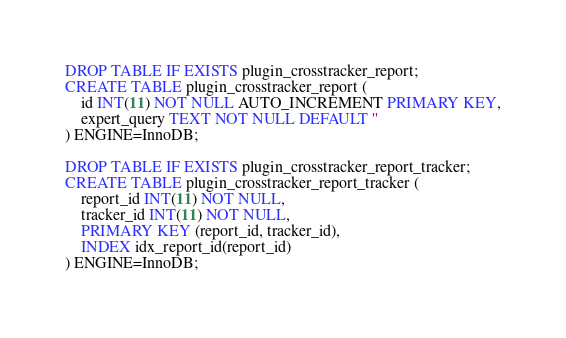<code> <loc_0><loc_0><loc_500><loc_500><_SQL_>DROP TABLE IF EXISTS plugin_crosstracker_report;
CREATE TABLE plugin_crosstracker_report (
    id INT(11) NOT NULL AUTO_INCREMENT PRIMARY KEY,
    expert_query TEXT NOT NULL DEFAULT ''
) ENGINE=InnoDB;

DROP TABLE IF EXISTS plugin_crosstracker_report_tracker;
CREATE TABLE plugin_crosstracker_report_tracker (
    report_id INT(11) NOT NULL,
    tracker_id INT(11) NOT NULL,
    PRIMARY KEY (report_id, tracker_id),
    INDEX idx_report_id(report_id)
) ENGINE=InnoDB;
</code> 